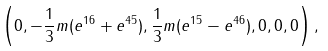Convert formula to latex. <formula><loc_0><loc_0><loc_500><loc_500>\left ( 0 , - \frac { 1 } { 3 } m ( e ^ { 1 6 } + e ^ { 4 5 } ) , \frac { 1 } { 3 } m ( e ^ { 1 5 } - e ^ { 4 6 } ) , 0 , 0 , 0 \right ) ,</formula> 